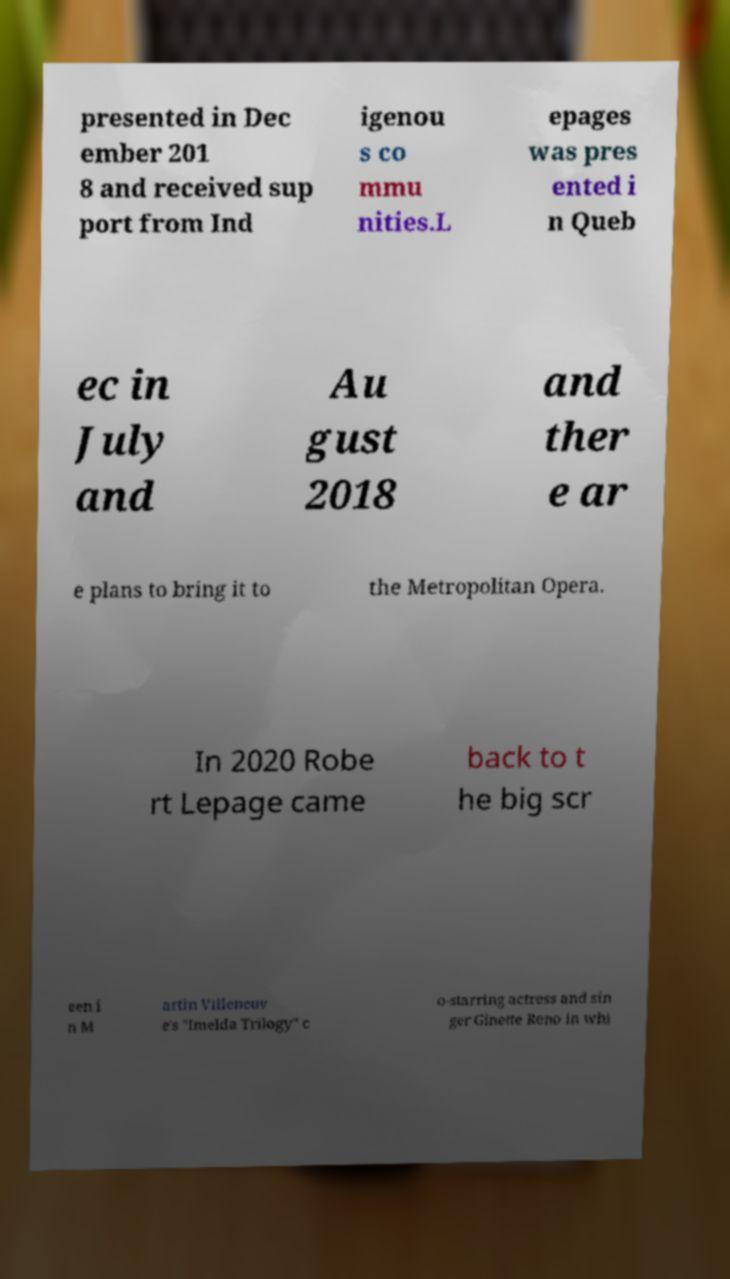Can you read and provide the text displayed in the image?This photo seems to have some interesting text. Can you extract and type it out for me? presented in Dec ember 201 8 and received sup port from Ind igenou s co mmu nities.L epages was pres ented i n Queb ec in July and Au gust 2018 and ther e ar e plans to bring it to the Metropolitan Opera. In 2020 Robe rt Lepage came back to t he big scr een i n M artin Villeneuv e's "Imelda Trilogy" c o-starring actress and sin ger Ginette Reno in whi 